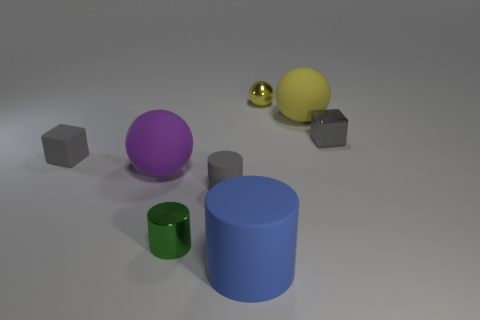Add 1 big blue spheres. How many objects exist? 9 Subtract all balls. How many objects are left? 5 Add 2 yellow metallic things. How many yellow metallic things are left? 3 Add 5 gray cylinders. How many gray cylinders exist? 6 Subtract 2 gray blocks. How many objects are left? 6 Subtract all yellow spheres. Subtract all red objects. How many objects are left? 6 